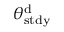Convert formula to latex. <formula><loc_0><loc_0><loc_500><loc_500>\theta _ { s t d y } ^ { d }</formula> 